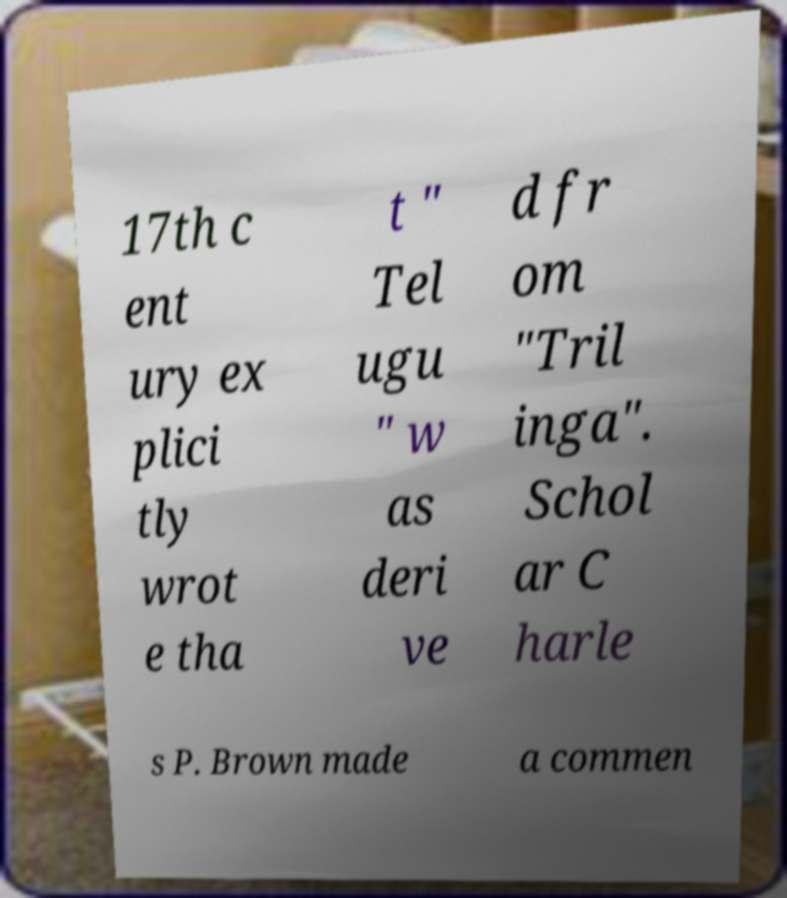For documentation purposes, I need the text within this image transcribed. Could you provide that? 17th c ent ury ex plici tly wrot e tha t " Tel ugu " w as deri ve d fr om "Tril inga". Schol ar C harle s P. Brown made a commen 